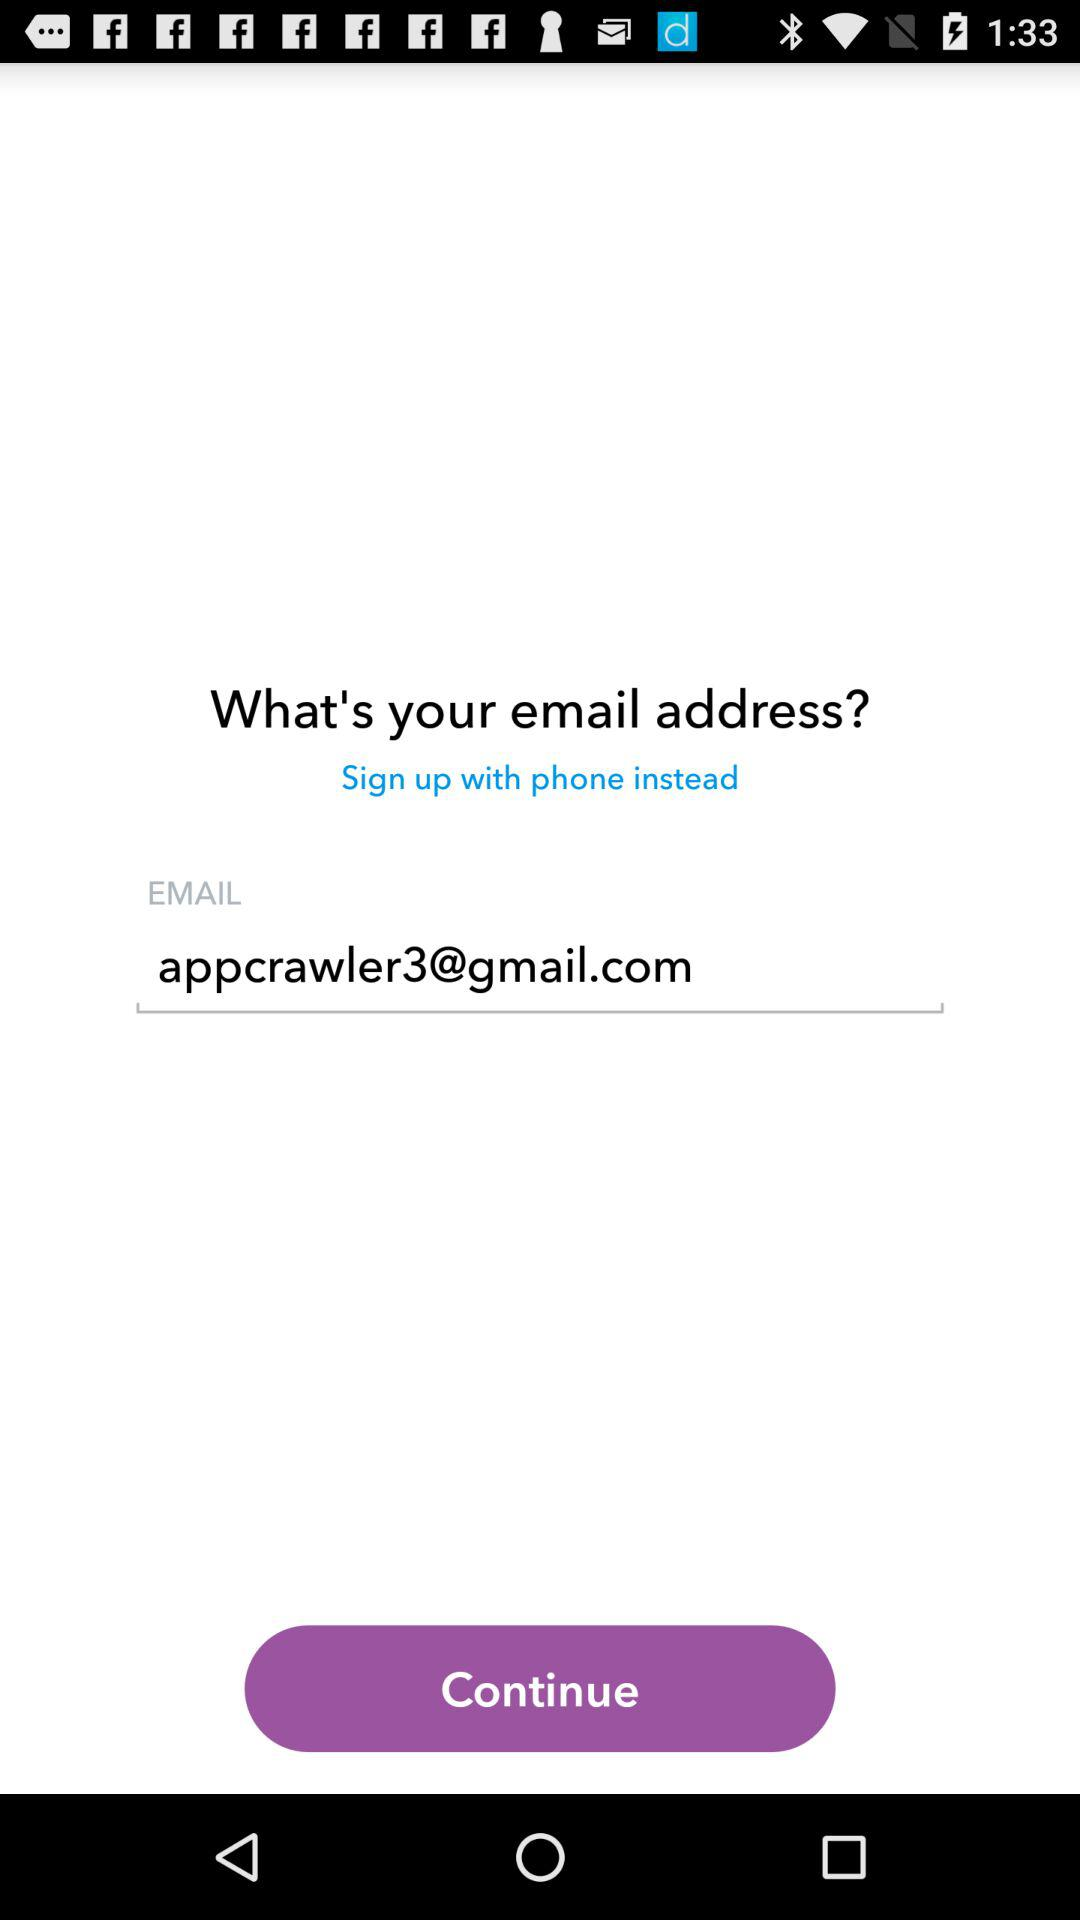What is the entered email address? The entered email address is appcrawler3@gmail.com. 